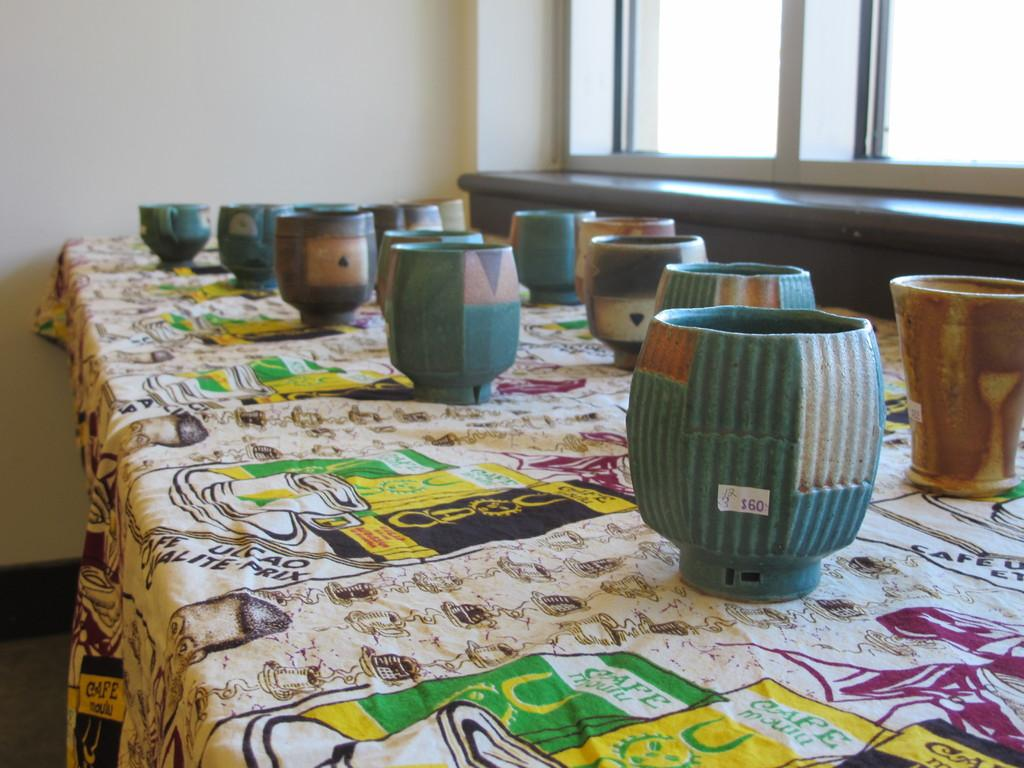What objects are visible in the image that are used for holding plants or water? There are multiple pots in the image that are used for holding plants or water. How can you tell the price of some of the pots in the image? Price tags are present on some of the pots in the image. What is covering the table in the image? There is a tablecloth in the image. Can you describe the appearance of the tablecloth? The tablecloth has designs on it and writing on it. Where is the tub located in the image? There is no tub present in the image. What type of hole can be seen in the image? There is no hole present in the image. 